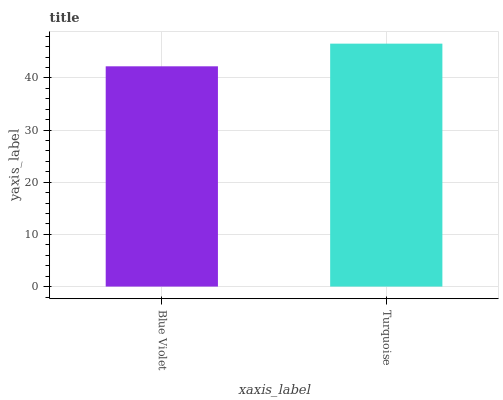Is Blue Violet the minimum?
Answer yes or no. Yes. Is Turquoise the maximum?
Answer yes or no. Yes. Is Turquoise the minimum?
Answer yes or no. No. Is Turquoise greater than Blue Violet?
Answer yes or no. Yes. Is Blue Violet less than Turquoise?
Answer yes or no. Yes. Is Blue Violet greater than Turquoise?
Answer yes or no. No. Is Turquoise less than Blue Violet?
Answer yes or no. No. Is Turquoise the high median?
Answer yes or no. Yes. Is Blue Violet the low median?
Answer yes or no. Yes. Is Blue Violet the high median?
Answer yes or no. No. Is Turquoise the low median?
Answer yes or no. No. 